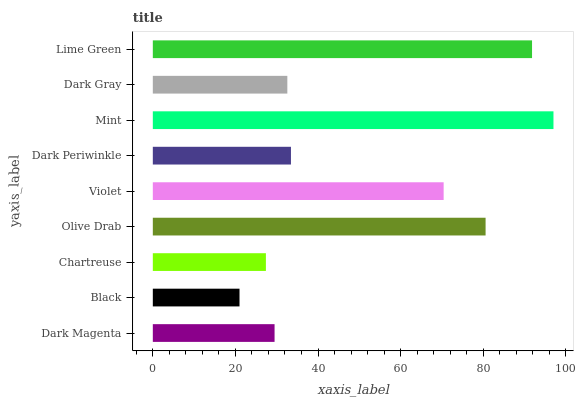Is Black the minimum?
Answer yes or no. Yes. Is Mint the maximum?
Answer yes or no. Yes. Is Chartreuse the minimum?
Answer yes or no. No. Is Chartreuse the maximum?
Answer yes or no. No. Is Chartreuse greater than Black?
Answer yes or no. Yes. Is Black less than Chartreuse?
Answer yes or no. Yes. Is Black greater than Chartreuse?
Answer yes or no. No. Is Chartreuse less than Black?
Answer yes or no. No. Is Dark Periwinkle the high median?
Answer yes or no. Yes. Is Dark Periwinkle the low median?
Answer yes or no. Yes. Is Dark Gray the high median?
Answer yes or no. No. Is Dark Gray the low median?
Answer yes or no. No. 